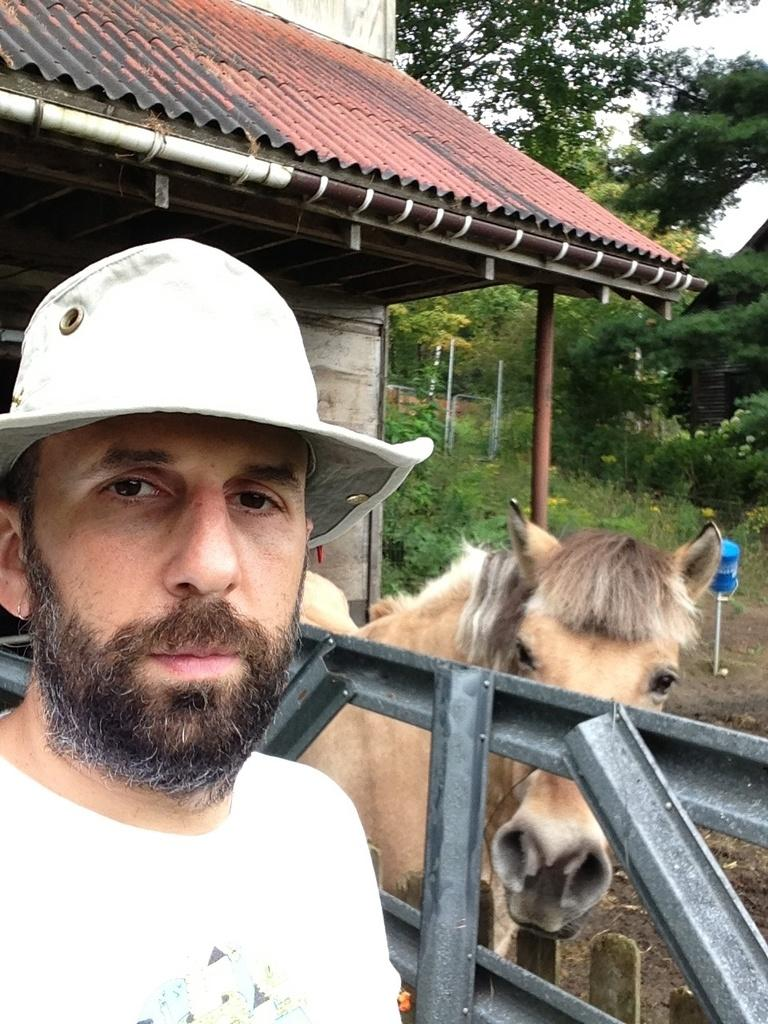What type of natural elements can be seen in the background of the image? There are trees and plants in the background of the image. What type of objects are present in the image? There are objects in the image, including poles and a railing. What type of structure is visible in the image? There is a roof top in the image. What type of animal is present in the image? There is an animal in the image. What is the man in the image wearing on his head? The man is wearing a hat. What is the man in the image wearing on his upper body? The man is wearing a t-shirt. How many mice are sitting on the throne in the image? There is no throne present in the image, and therefore no mice can be found sitting on it. What type of machine is being used by the man in the image? There is no machine visible in the image; the man is simply wearing a hat and t-shirt. 